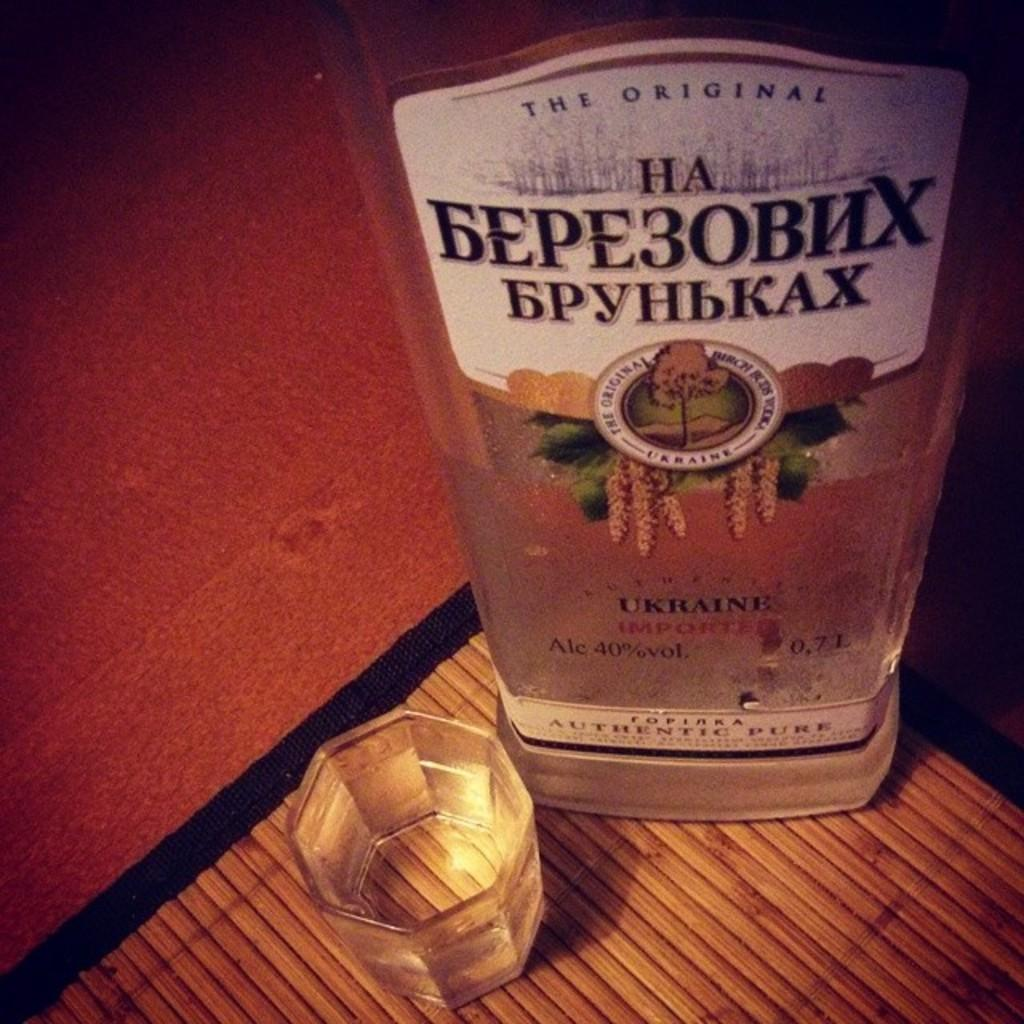Provide a one-sentence caption for the provided image. A bottle of alcohol from the Ukraine sits next to an octagonal drinking glass. 